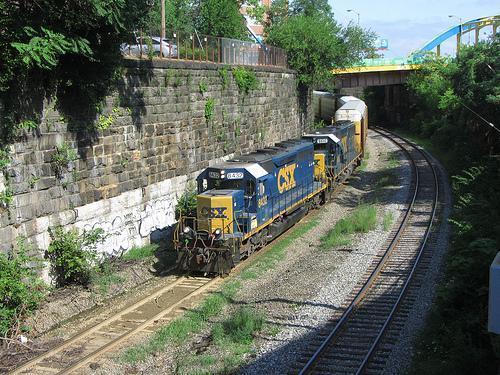How many trains are there?
Give a very brief answer. 1. 